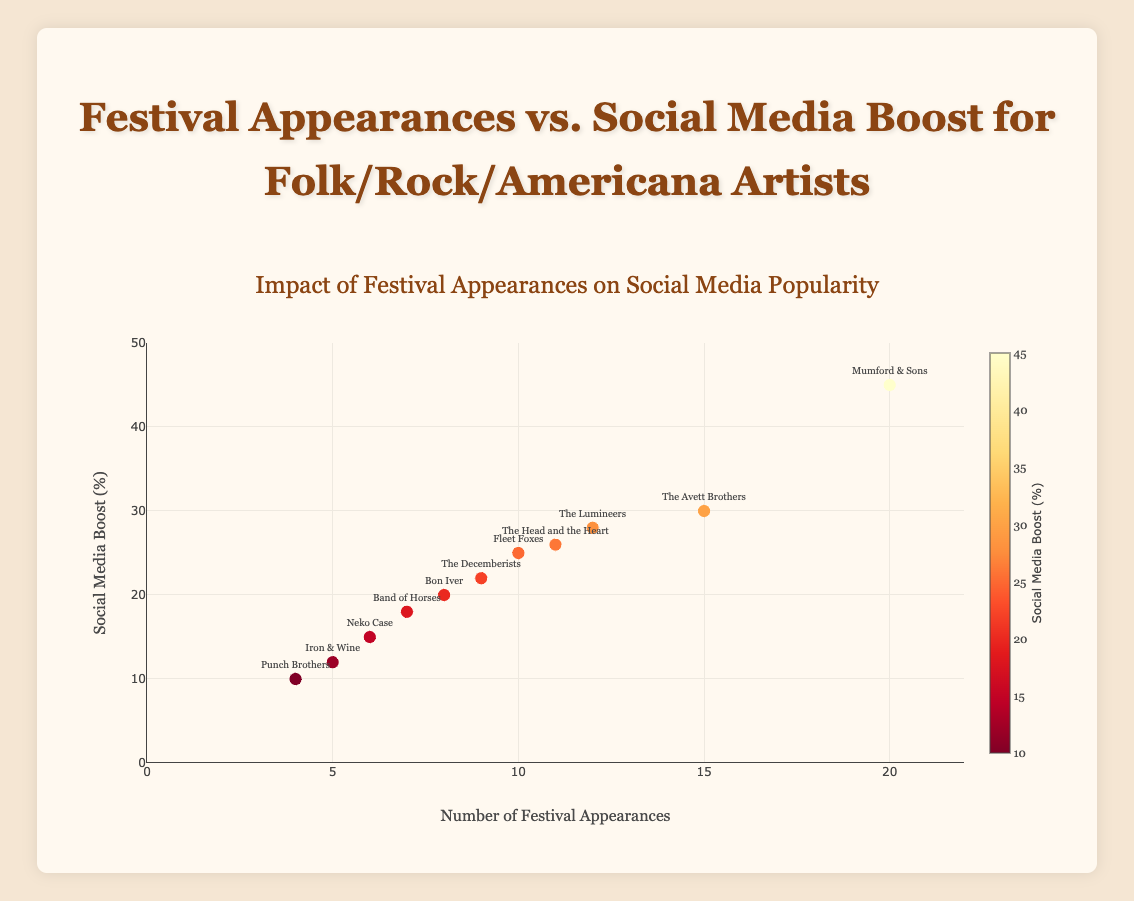What's the title of the plot? The title is prominently displayed at the top of the plot.
Answer: Festival Appearances vs. Social Media Boost for Folk/Rock/Americana Artists How many artists have more than 10 festival appearances? The plot shows festival appearances on the x-axis. By counting the markers to the right of the 10-mark, we see there are four artists.
Answer: 4 Which artist has the highest social media boost percentage? The y-axis represents the social media boost percentage. The highest point on the y-axis corresponds to Mumford & Sons.
Answer: Mumford & Sons What is the social media boost percentage for artists with exactly 8 festival appearances? Locate the data points where x-axis (festival appearances) is 8. The corresponding y-axis value shows 20%, which corresponds to Bon Iver.
Answer: 20% Compare the social media boost percentage between The Decemberists and Band of Horses. Which one is higher? Find The Decemberists and Band of Horses on the plot, compare their y-values. The Decemberists (22%) have a higher boost than Band of Horses (18%).
Answer: The Decemberists What's the average social media boost percentage for artists with less than 10 festival appearances? List the artists with less than 10 appearances (Bon Iver, Iron & Wine, Band of Horses, Punch Brothers, Neko Case, The Decemberists). Calculate the average: (20 + 12 + 18 + 10 + 15 + 22)/6.
Answer: 16.17% If an artist has more festival appearances, do they generally have a higher social media boost? Observe the overall trend in the scatter plot, noticing the tendency of higher y-values with higher x-values. Generally, yes.
Answer: Yes Identify the artist with the second lowest social media boost percentage. Find the second lowest data point on the y-axis, identifying Punch Brothers with 10%.
Answer: Punch Brothers Is the correlation between festival appearances and social media boost positive or negative? The trend in the scatter plot shows that as festival appearances increase, the social media boost also tends to increase.
Answer: Positive Which two artists have the closest social media boost percentages, and what are they? Identify closely positioned markers on the y-axis, which are Fleet Foxes (25%) and The Head and the Heart (26%).
Answer: Fleet Foxes and The Head and the Heart: 25%, 26% 